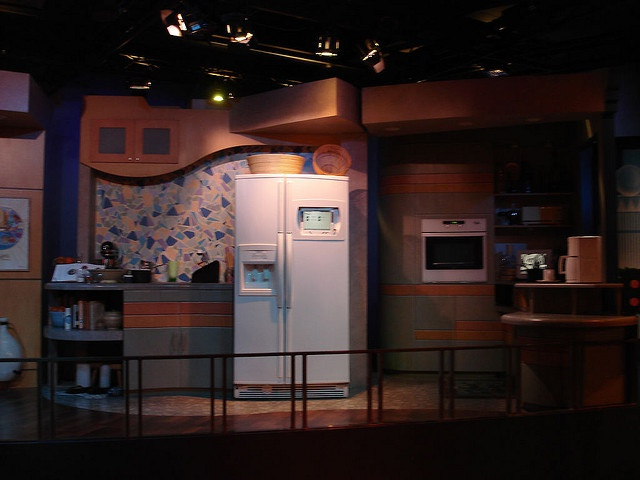Describe the objects in this image and their specific colors. I can see refrigerator in black, gray, pink, and lightgray tones, oven in black, brown, and maroon tones, bowl in black, maroon, and brown tones, bowl in black, tan, and salmon tones, and bowl in black and gray tones in this image. 